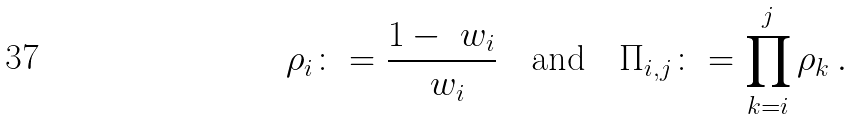Convert formula to latex. <formula><loc_0><loc_0><loc_500><loc_500>\rho _ { i } \colon = \frac { 1 - \ w _ { i } } { \ w _ { i } } \quad \text {and} \quad \Pi _ { i , j } \colon = \prod _ { k = i } ^ { j } \rho _ { k } \, .</formula> 